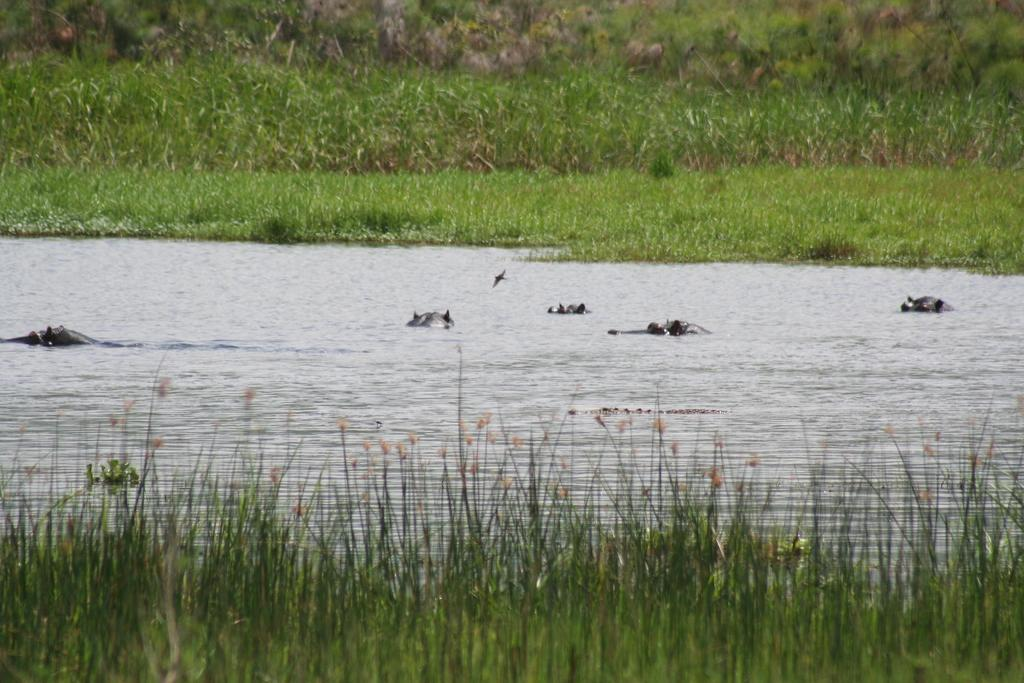What are the animals doing in the water? The animals are swimming in the water. What type of vegetation can be seen on the ground? There are plants on the ground. What is the ground covered with? The ground is covered with grass. How many rabbits can be seen hopping on the grass in the image? There are no rabbits present in the image; it features animals swimming in the water and plants on the ground. What type of friction is present between the animals and the water in the image? The provided facts do not mention any specific type of friction between the animals and the water in the image. 